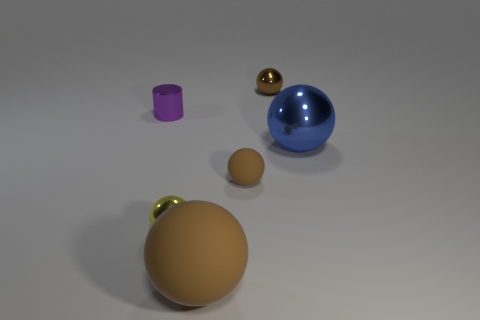Is there another small ball that has the same color as the tiny rubber sphere?
Provide a succinct answer. Yes. There is another tiny sphere that is the same color as the tiny matte sphere; what material is it?
Your response must be concise. Metal. Is the color of the small matte thing the same as the large matte object?
Your response must be concise. Yes. The yellow object that is the same shape as the big blue thing is what size?
Offer a terse response. Small. What is the shape of the small brown metal thing?
Offer a very short reply. Sphere. What is the shape of the brown object that is the same size as the brown metal ball?
Make the answer very short. Sphere. Are there any other things of the same color as the small matte object?
Ensure brevity in your answer.  Yes. What size is the blue ball that is made of the same material as the small yellow thing?
Ensure brevity in your answer.  Large. There is a large brown matte object; is it the same shape as the tiny metallic thing that is on the left side of the yellow object?
Ensure brevity in your answer.  No. The blue metallic ball has what size?
Provide a succinct answer. Large. 